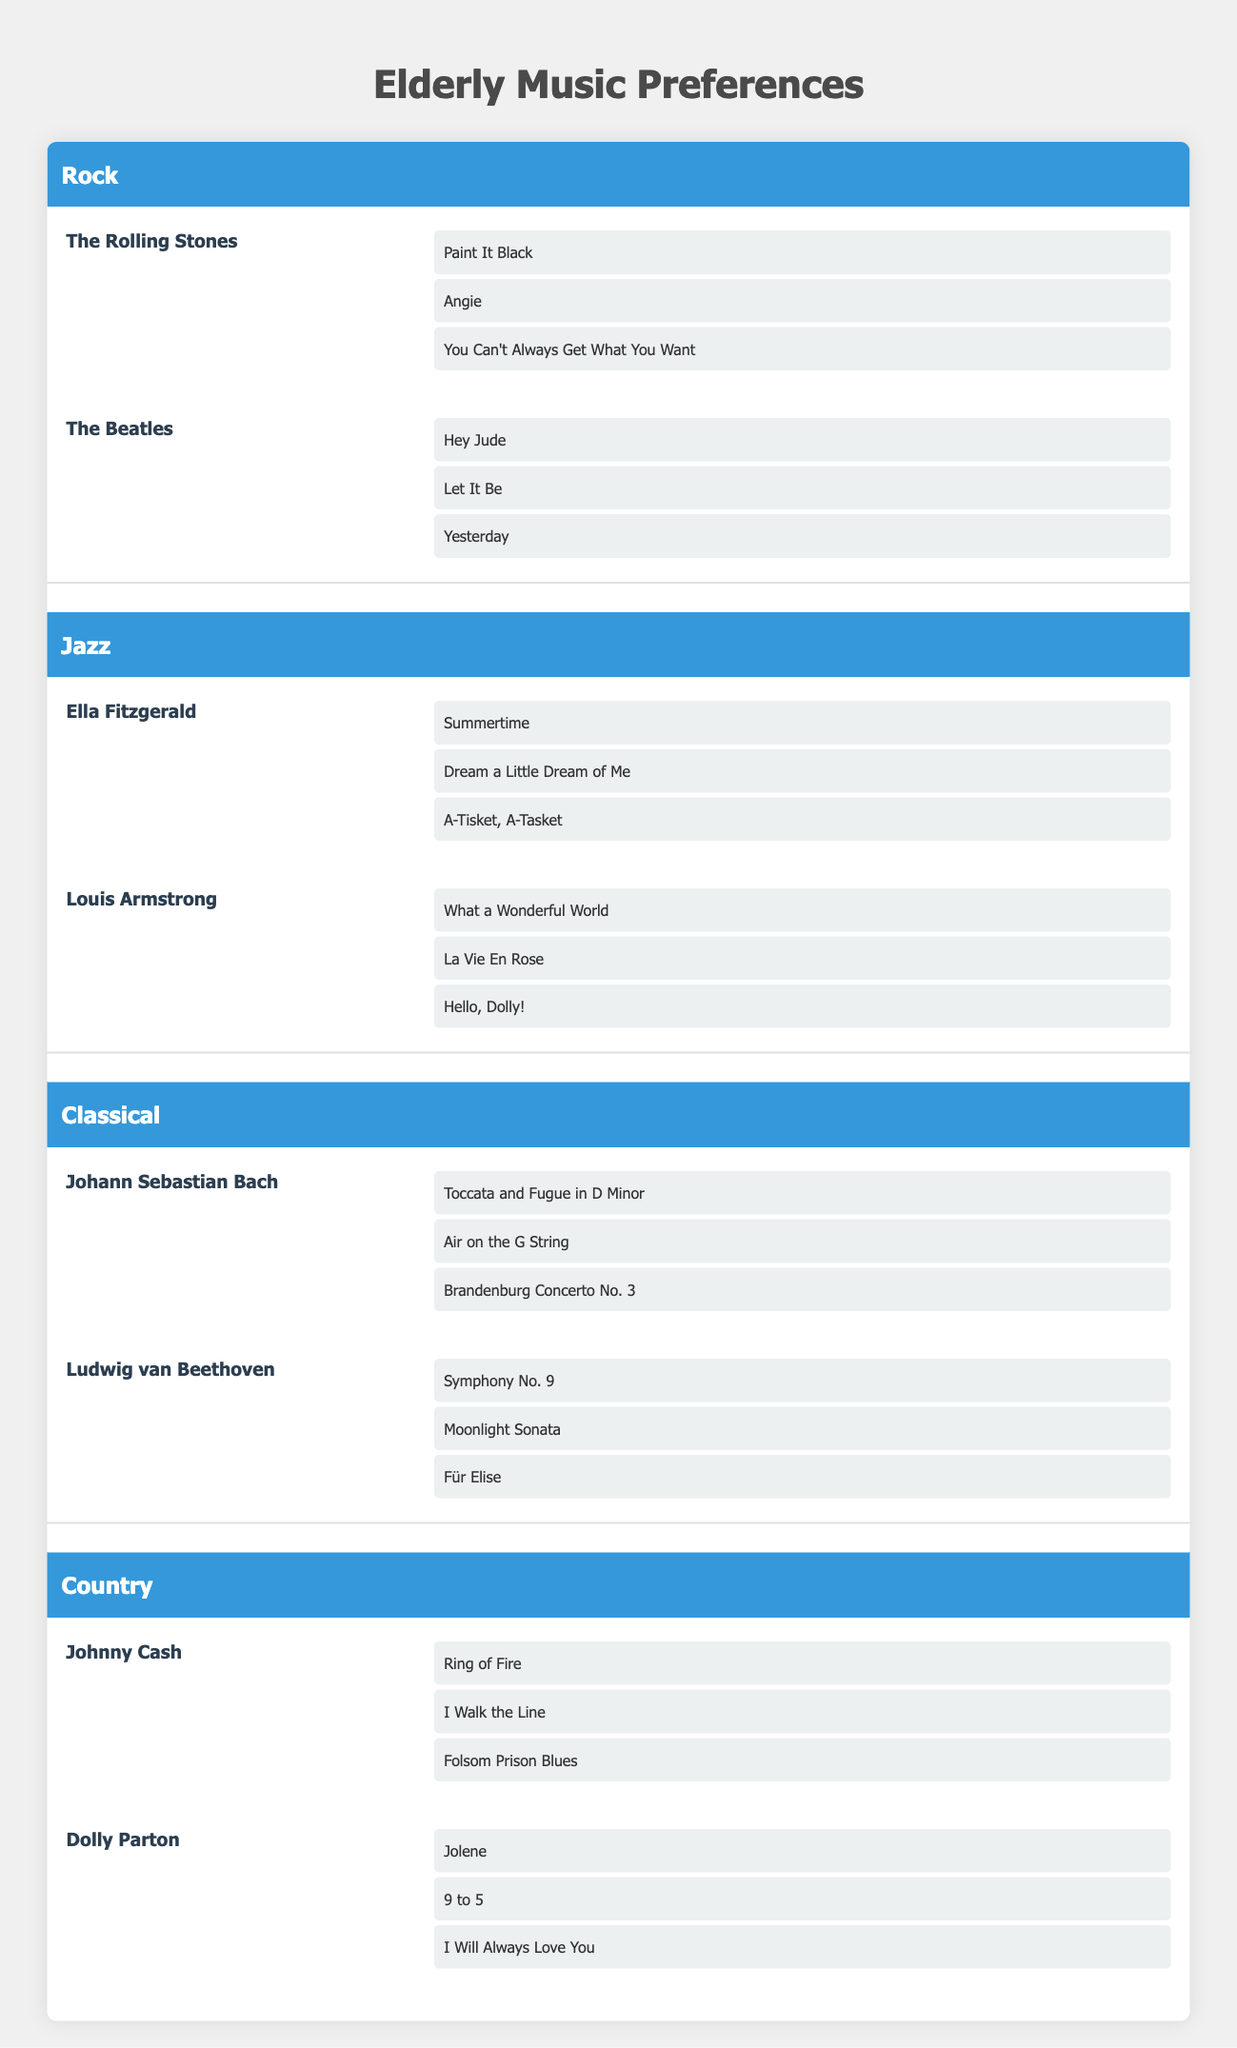What are the top songs of The Beatles? The top songs of The Beatles listed under the Rock genre are Hey Jude, Let It Be, and Yesterday.
Answer: Hey Jude, Let It Be, Yesterday Which artist from the Jazz genre has the song "What a Wonderful World"? "What a Wonderful World" is listed as one of the top songs of Louis Armstrong, who is also categorized under the Jazz genre.
Answer: Louis Armstrong How many total artists are listed in the Country genre? The Country genre lists two artists: Johnny Cash and Dolly Parton. Therefore, the total number of artists is 2.
Answer: 2 Is "Moonlight Sonata" a song by Johann Sebastian Bach? "Moonlight Sonata" is found under the Classical genre, but it is listed as a top song of Ludwig van Beethoven, not Johann Sebastian Bach.
Answer: No If you combine the top songs from Rock and Jazz genres, how many total songs do you have? The Rock genre has a total of 6 songs (3 from each artist), and the Jazz genre also has a total of 6 songs. Combining them gives 6 + 6 = 12 songs.
Answer: 12 What genre has the most artists listed? The genres Rock, Jazz, Classical, and Country all have 2 artists, which means no genre has more artists than others; they all equal out at 2 each.
Answer: No genre has more artists Which artist has the most songs listed, and what are they? Each artist listed has 3 top songs, so there is no individual artist with more songs than others in this table. They all have the same number of songs.
Answer: None Are all artists featured in the table male? The table features both male (e.g., Johnny Cash, The Rolling Stones) and female artists (e.g., Dolly Parton, Ella Fitzgerald), so not all of them are male.
Answer: No 